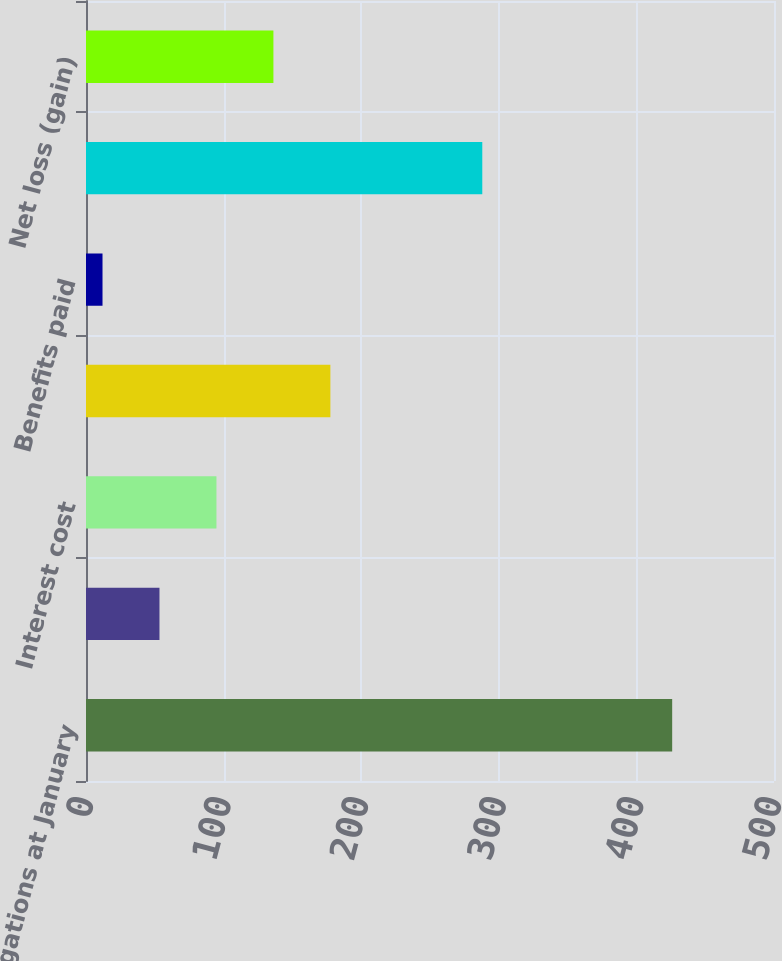Convert chart. <chart><loc_0><loc_0><loc_500><loc_500><bar_chart><fcel>Benefit obligations at January<fcel>Service cost<fcel>Interest cost<fcel>Actuarial loss (gain)<fcel>Benefits paid<fcel>Benefit obligations at<fcel>Net loss (gain)<nl><fcel>426<fcel>53.4<fcel>94.8<fcel>177.6<fcel>12<fcel>288<fcel>136.2<nl></chart> 